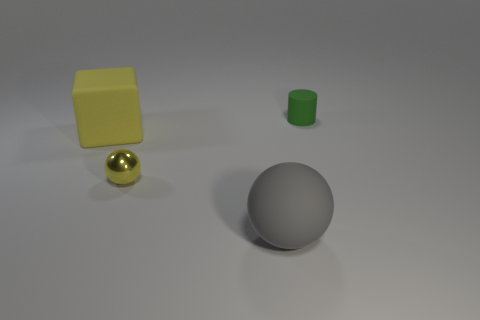Add 2 large brown rubber cylinders. How many objects exist? 6 Subtract all cylinders. How many objects are left? 3 Subtract all small things. Subtract all blue rubber things. How many objects are left? 2 Add 1 tiny yellow spheres. How many tiny yellow spheres are left? 2 Add 4 spheres. How many spheres exist? 6 Subtract 0 brown cubes. How many objects are left? 4 